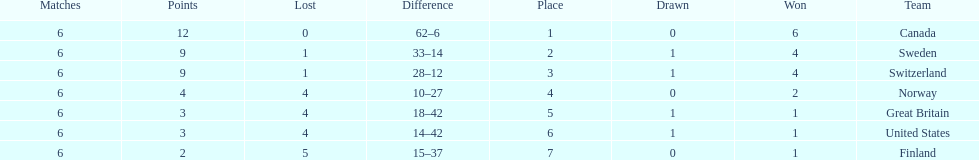How many teams won at least 4 matches? 3. 